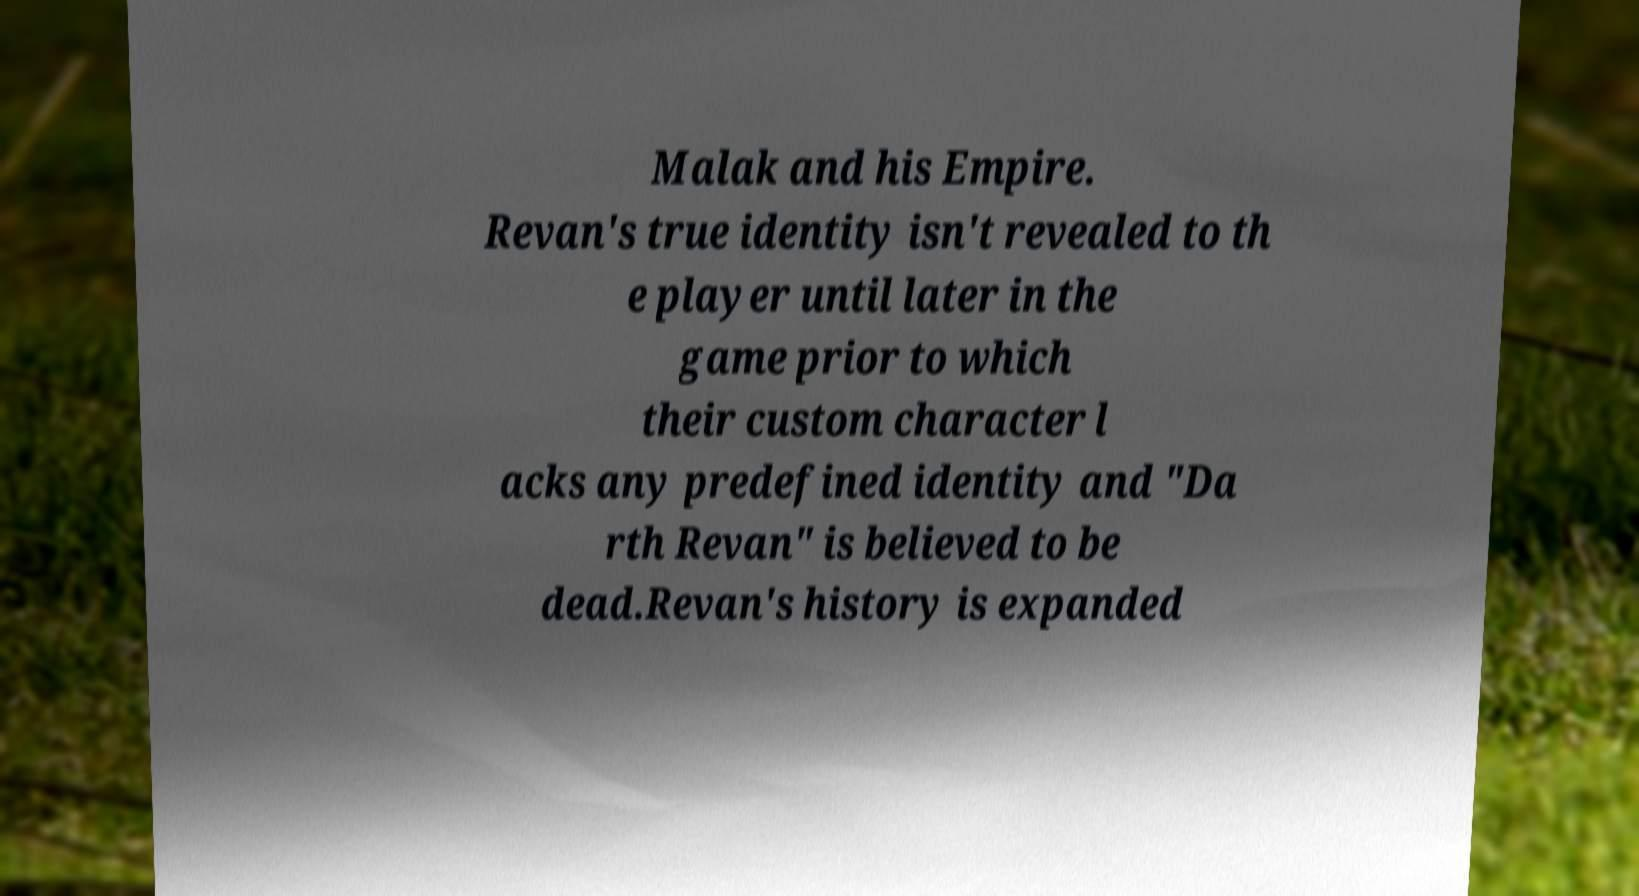I need the written content from this picture converted into text. Can you do that? Malak and his Empire. Revan's true identity isn't revealed to th e player until later in the game prior to which their custom character l acks any predefined identity and "Da rth Revan" is believed to be dead.Revan's history is expanded 